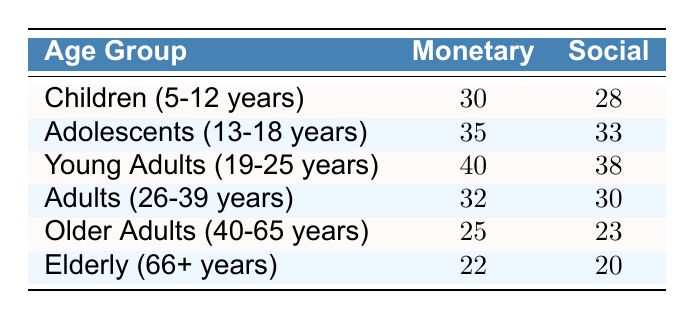What is the dopamine receptor expression level in children for the monetary reward condition? The table indicates that the expression level for Children (5-12 years) under the monetary reward condition is 30.
Answer: 30 What is the dopamine receptor expression level in adolescents for the social reward condition? Looking at the table, the expression level for Adolescents (13-18 years) under the social reward condition is 33.
Answer: 33 Which age group has the highest expression level for the monetary reward condition? The Young Adults (19-25 years) have the highest expression level of 40 in the monetary reward condition when comparing all age groups listed.
Answer: Young Adults (19-25 years) What is the difference in dopamine receptor expression levels between young adults and older adults for the social reward condition? For Young Adults (19-25 years), the expression level is 38 and for Older Adults (40-65 years), it is 23. The difference is 38 - 23 = 15.
Answer: 15 Is the expression level for the social reward condition in adolescents higher than that in children? The expression level for adolescents (33) is higher than for children (28) in the social reward condition, making this statement true.
Answer: Yes What is the average dopamine receptor expression level for all age groups under the monetary reward condition? The expression levels for the monetary reward condition are 30 (children), 35 (adolescents), 40 (young adults), 32 (adults), 25 (older adults), and 22 (elderly), leading to a sum of 30 + 35 + 40 + 32 + 25 + 22 = 214. There are 6 data points, so the average is 214 / 6 = 35.67.
Answer: 35.67 For which reward condition does the elderly age group show higher dopamine receptor expression levels? Looking at the data, for the elderly (66+ years), the expression level is higher for the monetary condition (22) compared to the social condition (20).
Answer: Monetary What is the overall trend in dopamine receptor expression levels from childhood to elderly for the monetary reward condition? By examining the expression levels in the monetary reward condition (30 - children, 35 - adolescents, 40 - young adults, 32 - adults, 25 - older adults, 22 - elderly), we see that there is an increase till young adults, followed by a decrease in older and elderly adults, indicating a peak in young adulthood.
Answer: Increases to young adulthood, then decreases How does the dopamine receptor expression level for the social reward condition change from adolescents to elderly? The expression levels for the social reward condition are 33 (adolescents), 38 (young adults), 30 (adults), 23 (older adults), and 20 (elderly). This shows a decrease from adolescents to elderly.
Answer: Decreases 